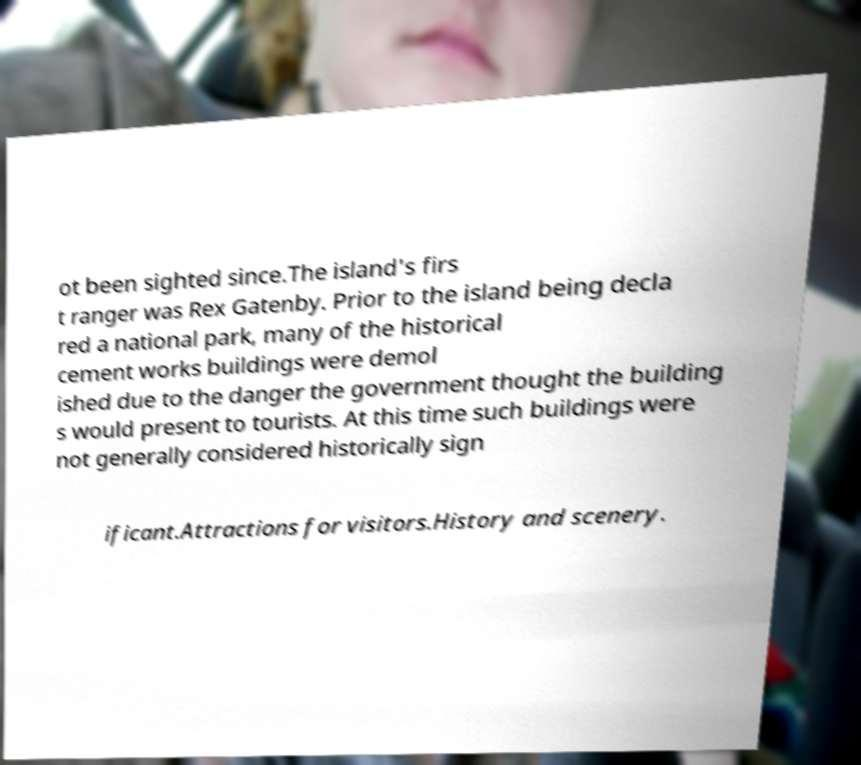Could you extract and type out the text from this image? ot been sighted since.The island's firs t ranger was Rex Gatenby. Prior to the island being decla red a national park, many of the historical cement works buildings were demol ished due to the danger the government thought the building s would present to tourists. At this time such buildings were not generally considered historically sign ificant.Attractions for visitors.History and scenery. 